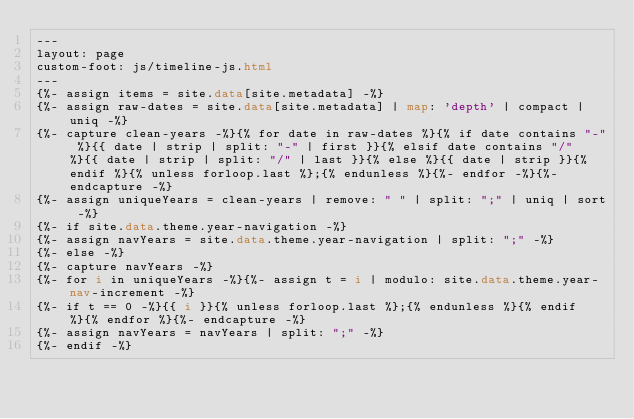<code> <loc_0><loc_0><loc_500><loc_500><_HTML_>---
layout: page
custom-foot: js/timeline-js.html
---
{%- assign items = site.data[site.metadata] -%}
{%- assign raw-dates = site.data[site.metadata] | map: 'depth' | compact | uniq -%}
{%- capture clean-years -%}{% for date in raw-dates %}{% if date contains "-" %}{{ date | strip | split: "-" | first }}{% elsif date contains "/" %}{{ date | strip | split: "/" | last }}{% else %}{{ date | strip }}{% endif %}{% unless forloop.last %};{% endunless %}{%- endfor -%}{%- endcapture -%}
{%- assign uniqueYears = clean-years | remove: " " | split: ";" | uniq | sort -%}
{%- if site.data.theme.year-navigation -%}
{%- assign navYears = site.data.theme.year-navigation | split: ";" -%}
{%- else -%}
{%- capture navYears -%}
{%- for i in uniqueYears -%}{%- assign t = i | modulo: site.data.theme.year-nav-increment -%}
{%- if t == 0 -%}{{ i }}{% unless forloop.last %};{% endunless %}{% endif %}{% endfor %}{%- endcapture -%}
{%- assign navYears = navYears | split: ";" -%}
{%- endif -%}</code> 